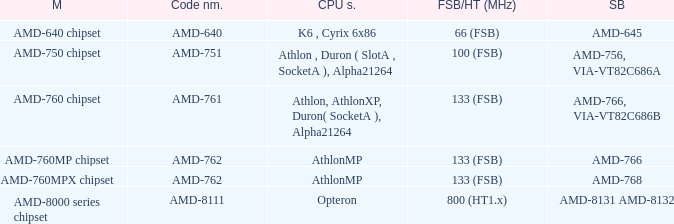What is the code name for an fsb/ht with a frequency of 100 mhz (fsb)? AMD-751. 